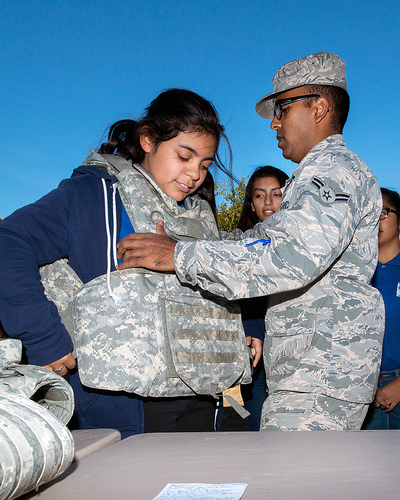<image>
Is the hat above the table? No. The hat is not positioned above the table. The vertical arrangement shows a different relationship. 